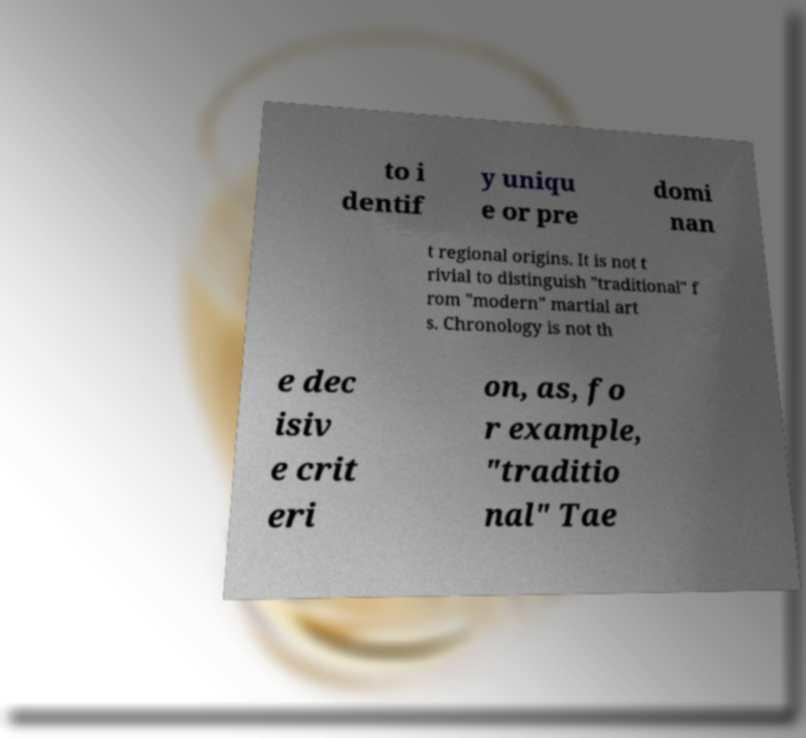Can you read and provide the text displayed in the image?This photo seems to have some interesting text. Can you extract and type it out for me? to i dentif y uniqu e or pre domi nan t regional origins. It is not t rivial to distinguish "traditional" f rom "modern" martial art s. Chronology is not th e dec isiv e crit eri on, as, fo r example, "traditio nal" Tae 